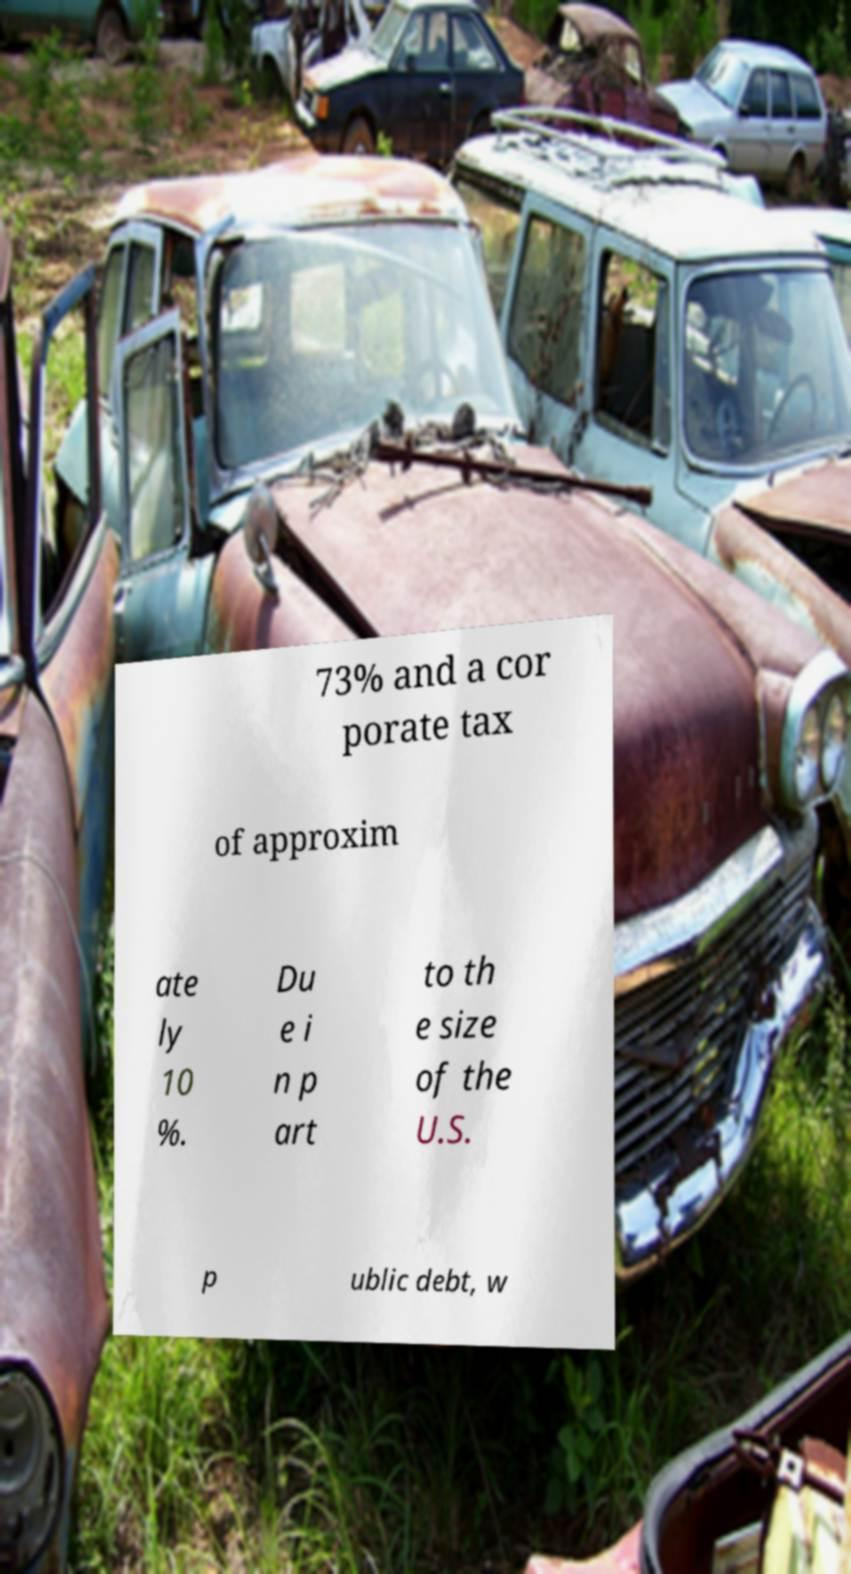Could you assist in decoding the text presented in this image and type it out clearly? 73% and a cor porate tax of approxim ate ly 10 %. Du e i n p art to th e size of the U.S. p ublic debt, w 